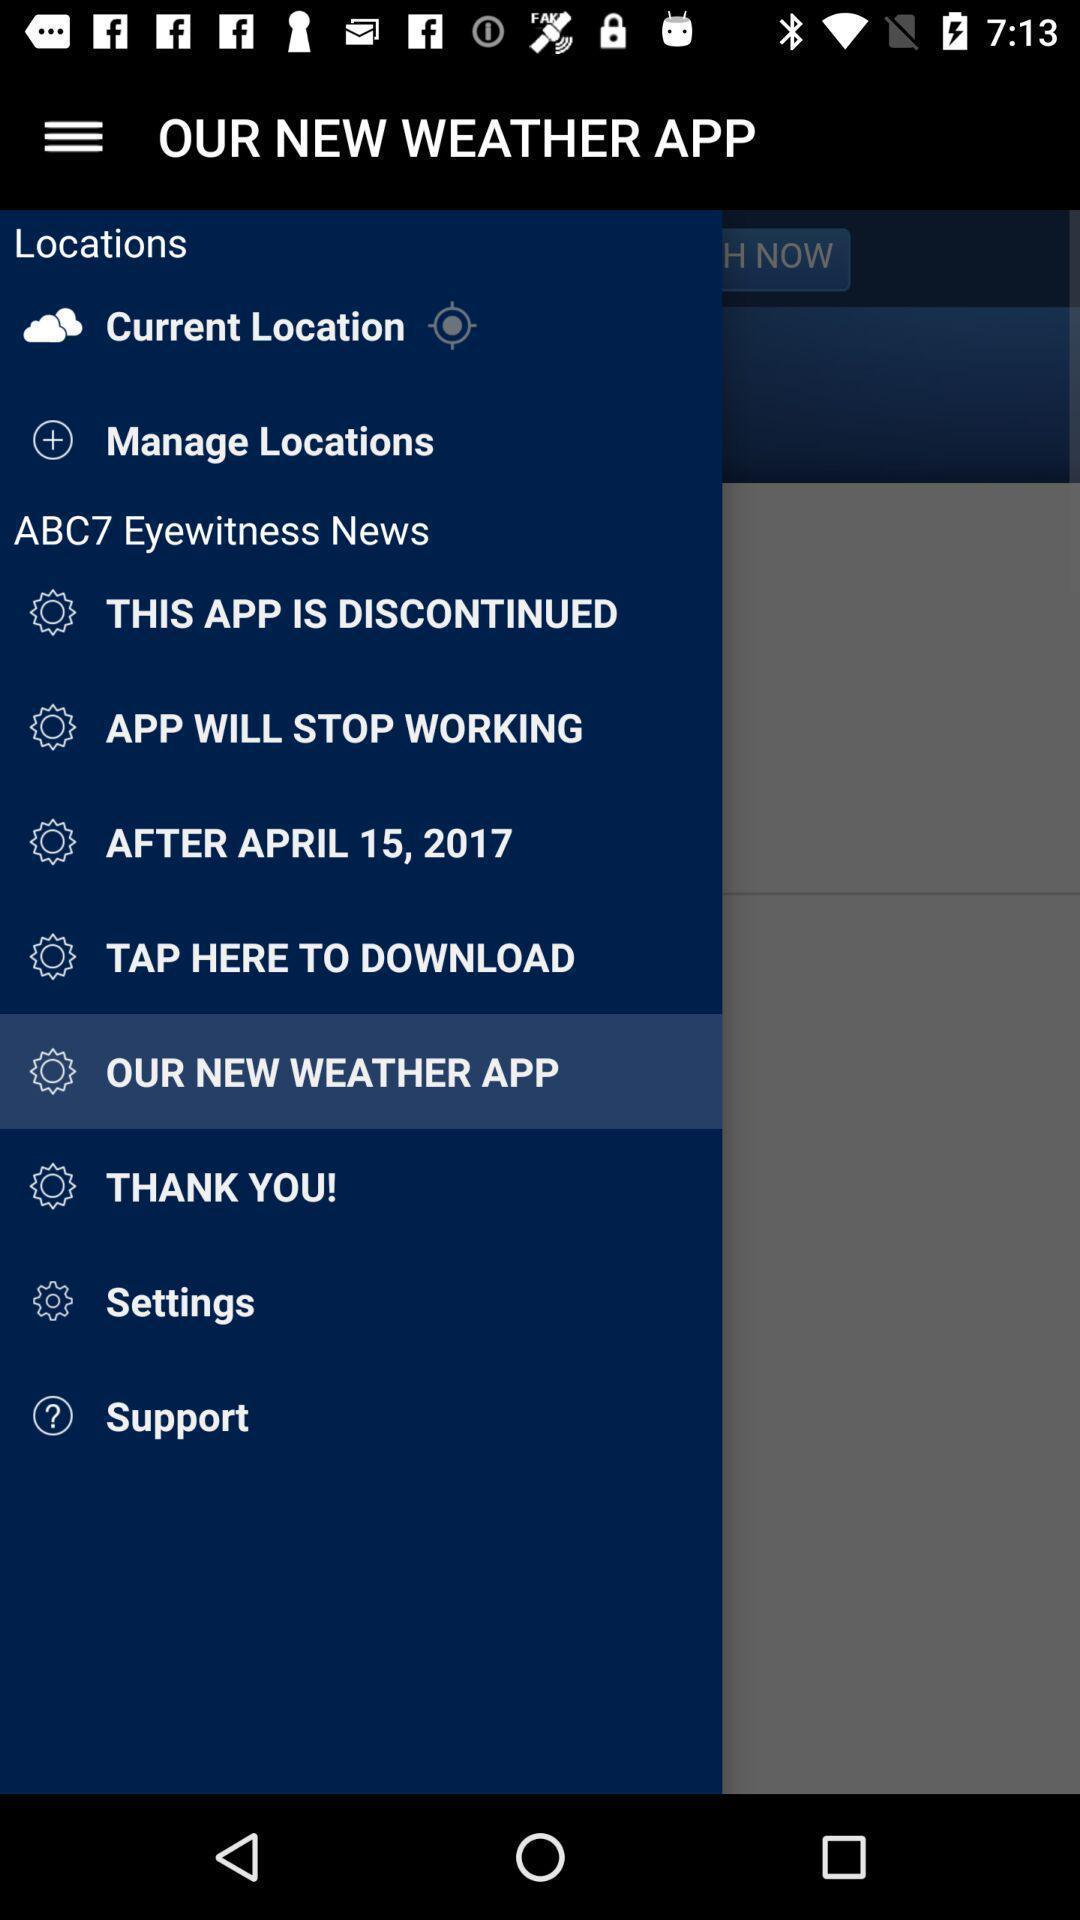Tell me what you see in this picture. Screen showing page of an weather application with options. 